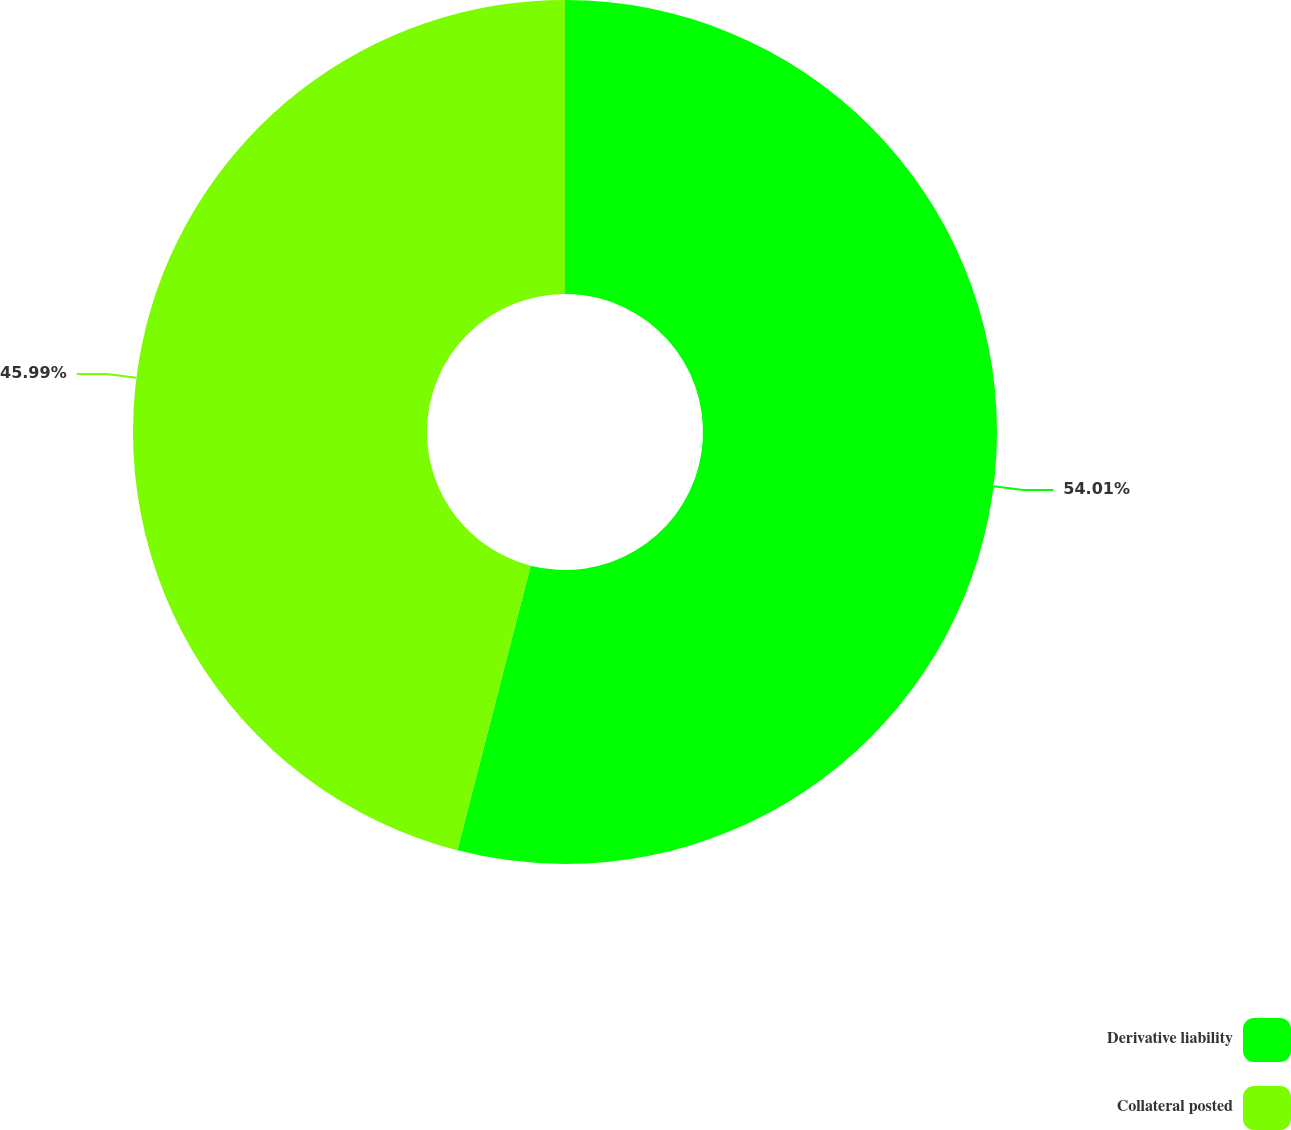<chart> <loc_0><loc_0><loc_500><loc_500><pie_chart><fcel>Derivative liability<fcel>Collateral posted<nl><fcel>54.01%<fcel>45.99%<nl></chart> 